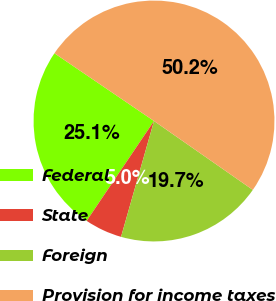<chart> <loc_0><loc_0><loc_500><loc_500><pie_chart><fcel>Federal<fcel>State<fcel>Foreign<fcel>Provision for income taxes<nl><fcel>25.06%<fcel>5.03%<fcel>19.72%<fcel>50.18%<nl></chart> 